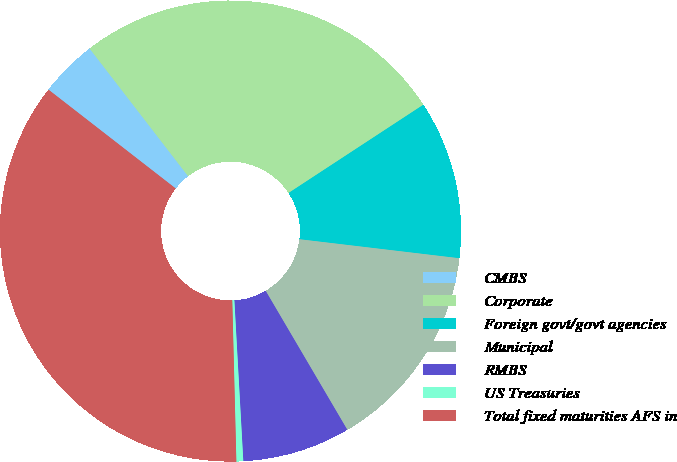Convert chart. <chart><loc_0><loc_0><loc_500><loc_500><pie_chart><fcel>CMBS<fcel>Corporate<fcel>Foreign govt/govt agencies<fcel>Municipal<fcel>RMBS<fcel>US Treasuries<fcel>Total fixed maturities AFS in<nl><fcel>4.03%<fcel>26.23%<fcel>11.11%<fcel>14.66%<fcel>7.57%<fcel>0.48%<fcel>35.91%<nl></chart> 